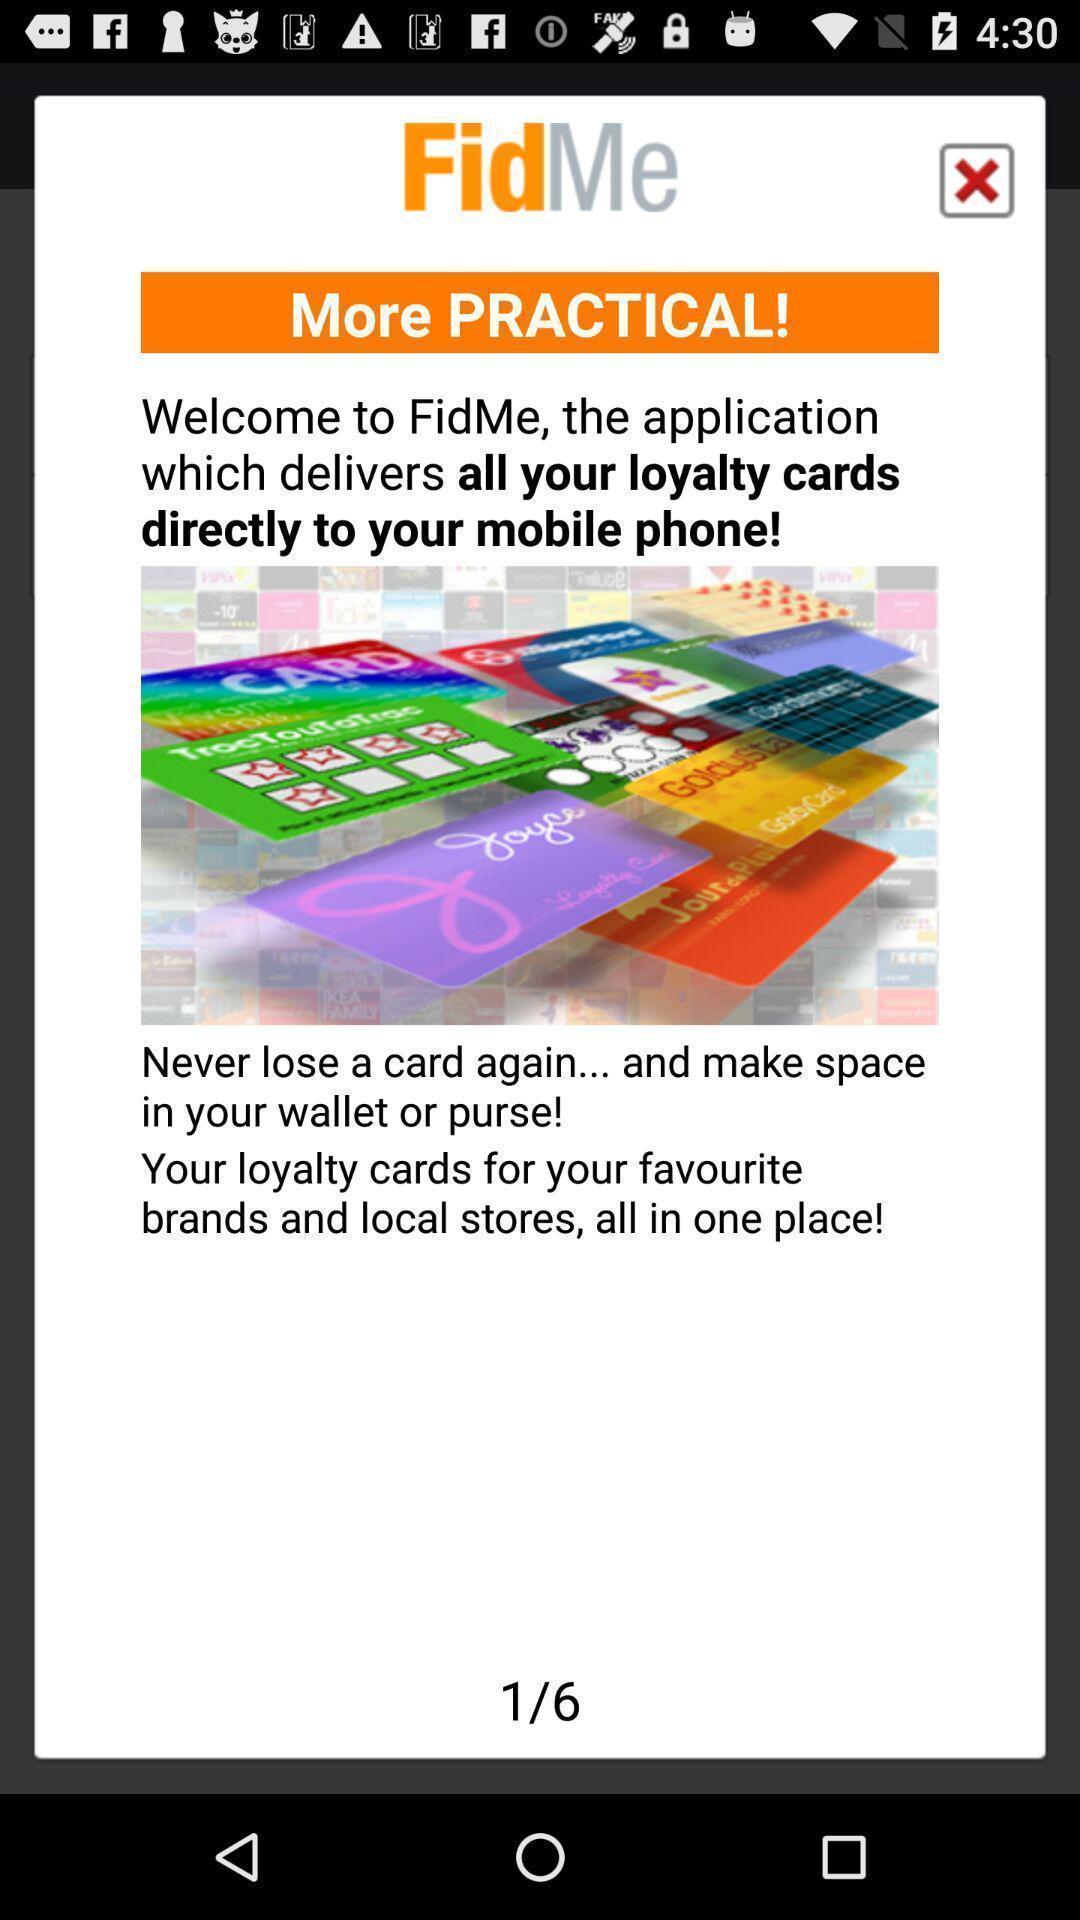What details can you identify in this image? Popup of the text with welcome note. 